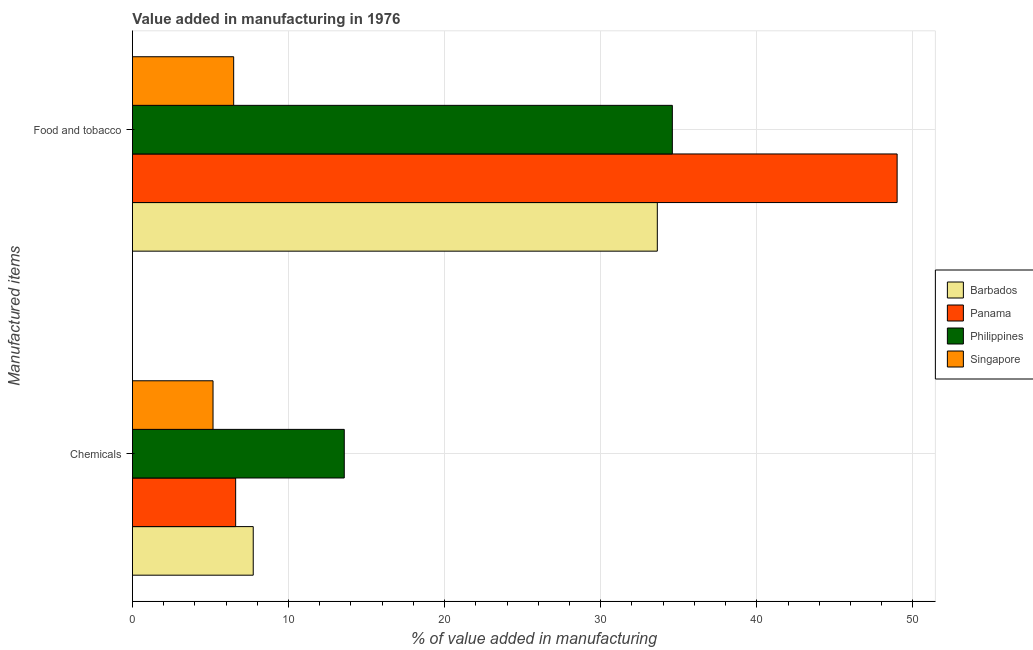How many groups of bars are there?
Give a very brief answer. 2. Are the number of bars per tick equal to the number of legend labels?
Your response must be concise. Yes. How many bars are there on the 1st tick from the top?
Give a very brief answer. 4. What is the label of the 2nd group of bars from the top?
Your answer should be compact. Chemicals. What is the value added by manufacturing food and tobacco in Singapore?
Your answer should be compact. 6.49. Across all countries, what is the maximum value added by  manufacturing chemicals?
Your response must be concise. 13.57. Across all countries, what is the minimum value added by manufacturing food and tobacco?
Give a very brief answer. 6.49. In which country was the value added by manufacturing food and tobacco maximum?
Your response must be concise. Panama. In which country was the value added by  manufacturing chemicals minimum?
Give a very brief answer. Singapore. What is the total value added by  manufacturing chemicals in the graph?
Offer a very short reply. 33.09. What is the difference between the value added by  manufacturing chemicals in Panama and that in Barbados?
Your answer should be very brief. -1.13. What is the difference between the value added by  manufacturing chemicals in Philippines and the value added by manufacturing food and tobacco in Singapore?
Make the answer very short. 7.09. What is the average value added by manufacturing food and tobacco per country?
Provide a succinct answer. 30.92. What is the difference between the value added by  manufacturing chemicals and value added by manufacturing food and tobacco in Panama?
Make the answer very short. -42.38. What is the ratio of the value added by  manufacturing chemicals in Panama to that in Philippines?
Your answer should be very brief. 0.49. In how many countries, is the value added by  manufacturing chemicals greater than the average value added by  manufacturing chemicals taken over all countries?
Your response must be concise. 1. What does the 2nd bar from the bottom in Chemicals represents?
Provide a succinct answer. Panama. How many bars are there?
Ensure brevity in your answer.  8. Are all the bars in the graph horizontal?
Offer a very short reply. Yes. Are the values on the major ticks of X-axis written in scientific E-notation?
Provide a succinct answer. No. Does the graph contain any zero values?
Offer a very short reply. No. Where does the legend appear in the graph?
Offer a very short reply. Center right. What is the title of the graph?
Give a very brief answer. Value added in manufacturing in 1976. Does "Canada" appear as one of the legend labels in the graph?
Your answer should be very brief. No. What is the label or title of the X-axis?
Make the answer very short. % of value added in manufacturing. What is the label or title of the Y-axis?
Your answer should be compact. Manufactured items. What is the % of value added in manufacturing of Barbados in Chemicals?
Keep it short and to the point. 7.74. What is the % of value added in manufacturing in Panama in Chemicals?
Ensure brevity in your answer.  6.61. What is the % of value added in manufacturing of Philippines in Chemicals?
Ensure brevity in your answer.  13.57. What is the % of value added in manufacturing in Singapore in Chemicals?
Your response must be concise. 5.16. What is the % of value added in manufacturing of Barbados in Food and tobacco?
Provide a short and direct response. 33.63. What is the % of value added in manufacturing in Panama in Food and tobacco?
Make the answer very short. 48.99. What is the % of value added in manufacturing of Philippines in Food and tobacco?
Provide a short and direct response. 34.59. What is the % of value added in manufacturing in Singapore in Food and tobacco?
Ensure brevity in your answer.  6.49. Across all Manufactured items, what is the maximum % of value added in manufacturing in Barbados?
Make the answer very short. 33.63. Across all Manufactured items, what is the maximum % of value added in manufacturing in Panama?
Offer a terse response. 48.99. Across all Manufactured items, what is the maximum % of value added in manufacturing in Philippines?
Your answer should be compact. 34.59. Across all Manufactured items, what is the maximum % of value added in manufacturing of Singapore?
Give a very brief answer. 6.49. Across all Manufactured items, what is the minimum % of value added in manufacturing in Barbados?
Give a very brief answer. 7.74. Across all Manufactured items, what is the minimum % of value added in manufacturing of Panama?
Your response must be concise. 6.61. Across all Manufactured items, what is the minimum % of value added in manufacturing in Philippines?
Make the answer very short. 13.57. Across all Manufactured items, what is the minimum % of value added in manufacturing of Singapore?
Provide a succinct answer. 5.16. What is the total % of value added in manufacturing in Barbados in the graph?
Offer a very short reply. 41.36. What is the total % of value added in manufacturing in Panama in the graph?
Offer a very short reply. 55.6. What is the total % of value added in manufacturing of Philippines in the graph?
Give a very brief answer. 48.16. What is the total % of value added in manufacturing of Singapore in the graph?
Offer a very short reply. 11.65. What is the difference between the % of value added in manufacturing of Barbados in Chemicals and that in Food and tobacco?
Your answer should be very brief. -25.89. What is the difference between the % of value added in manufacturing in Panama in Chemicals and that in Food and tobacco?
Give a very brief answer. -42.38. What is the difference between the % of value added in manufacturing of Philippines in Chemicals and that in Food and tobacco?
Your answer should be very brief. -21.02. What is the difference between the % of value added in manufacturing in Singapore in Chemicals and that in Food and tobacco?
Provide a short and direct response. -1.32. What is the difference between the % of value added in manufacturing of Barbados in Chemicals and the % of value added in manufacturing of Panama in Food and tobacco?
Offer a terse response. -41.25. What is the difference between the % of value added in manufacturing of Barbados in Chemicals and the % of value added in manufacturing of Philippines in Food and tobacco?
Your response must be concise. -26.85. What is the difference between the % of value added in manufacturing in Barbados in Chemicals and the % of value added in manufacturing in Singapore in Food and tobacco?
Keep it short and to the point. 1.25. What is the difference between the % of value added in manufacturing of Panama in Chemicals and the % of value added in manufacturing of Philippines in Food and tobacco?
Give a very brief answer. -27.98. What is the difference between the % of value added in manufacturing in Panama in Chemicals and the % of value added in manufacturing in Singapore in Food and tobacco?
Keep it short and to the point. 0.13. What is the difference between the % of value added in manufacturing of Philippines in Chemicals and the % of value added in manufacturing of Singapore in Food and tobacco?
Keep it short and to the point. 7.09. What is the average % of value added in manufacturing of Barbados per Manufactured items?
Your response must be concise. 20.68. What is the average % of value added in manufacturing of Panama per Manufactured items?
Your response must be concise. 27.8. What is the average % of value added in manufacturing of Philippines per Manufactured items?
Your response must be concise. 24.08. What is the average % of value added in manufacturing in Singapore per Manufactured items?
Provide a short and direct response. 5.82. What is the difference between the % of value added in manufacturing in Barbados and % of value added in manufacturing in Panama in Chemicals?
Give a very brief answer. 1.13. What is the difference between the % of value added in manufacturing in Barbados and % of value added in manufacturing in Philippines in Chemicals?
Offer a terse response. -5.83. What is the difference between the % of value added in manufacturing of Barbados and % of value added in manufacturing of Singapore in Chemicals?
Ensure brevity in your answer.  2.58. What is the difference between the % of value added in manufacturing in Panama and % of value added in manufacturing in Philippines in Chemicals?
Keep it short and to the point. -6.96. What is the difference between the % of value added in manufacturing of Panama and % of value added in manufacturing of Singapore in Chemicals?
Your response must be concise. 1.45. What is the difference between the % of value added in manufacturing of Philippines and % of value added in manufacturing of Singapore in Chemicals?
Give a very brief answer. 8.41. What is the difference between the % of value added in manufacturing in Barbados and % of value added in manufacturing in Panama in Food and tobacco?
Your answer should be very brief. -15.36. What is the difference between the % of value added in manufacturing in Barbados and % of value added in manufacturing in Philippines in Food and tobacco?
Your answer should be compact. -0.96. What is the difference between the % of value added in manufacturing of Barbados and % of value added in manufacturing of Singapore in Food and tobacco?
Your answer should be compact. 27.14. What is the difference between the % of value added in manufacturing in Panama and % of value added in manufacturing in Philippines in Food and tobacco?
Your answer should be very brief. 14.4. What is the difference between the % of value added in manufacturing of Panama and % of value added in manufacturing of Singapore in Food and tobacco?
Your answer should be very brief. 42.5. What is the difference between the % of value added in manufacturing in Philippines and % of value added in manufacturing in Singapore in Food and tobacco?
Give a very brief answer. 28.1. What is the ratio of the % of value added in manufacturing in Barbados in Chemicals to that in Food and tobacco?
Offer a very short reply. 0.23. What is the ratio of the % of value added in manufacturing in Panama in Chemicals to that in Food and tobacco?
Offer a terse response. 0.14. What is the ratio of the % of value added in manufacturing in Philippines in Chemicals to that in Food and tobacco?
Offer a terse response. 0.39. What is the ratio of the % of value added in manufacturing in Singapore in Chemicals to that in Food and tobacco?
Your answer should be compact. 0.8. What is the difference between the highest and the second highest % of value added in manufacturing of Barbados?
Your response must be concise. 25.89. What is the difference between the highest and the second highest % of value added in manufacturing in Panama?
Your answer should be compact. 42.38. What is the difference between the highest and the second highest % of value added in manufacturing in Philippines?
Ensure brevity in your answer.  21.02. What is the difference between the highest and the second highest % of value added in manufacturing in Singapore?
Keep it short and to the point. 1.32. What is the difference between the highest and the lowest % of value added in manufacturing in Barbados?
Your answer should be compact. 25.89. What is the difference between the highest and the lowest % of value added in manufacturing of Panama?
Your answer should be compact. 42.38. What is the difference between the highest and the lowest % of value added in manufacturing of Philippines?
Ensure brevity in your answer.  21.02. What is the difference between the highest and the lowest % of value added in manufacturing of Singapore?
Ensure brevity in your answer.  1.32. 